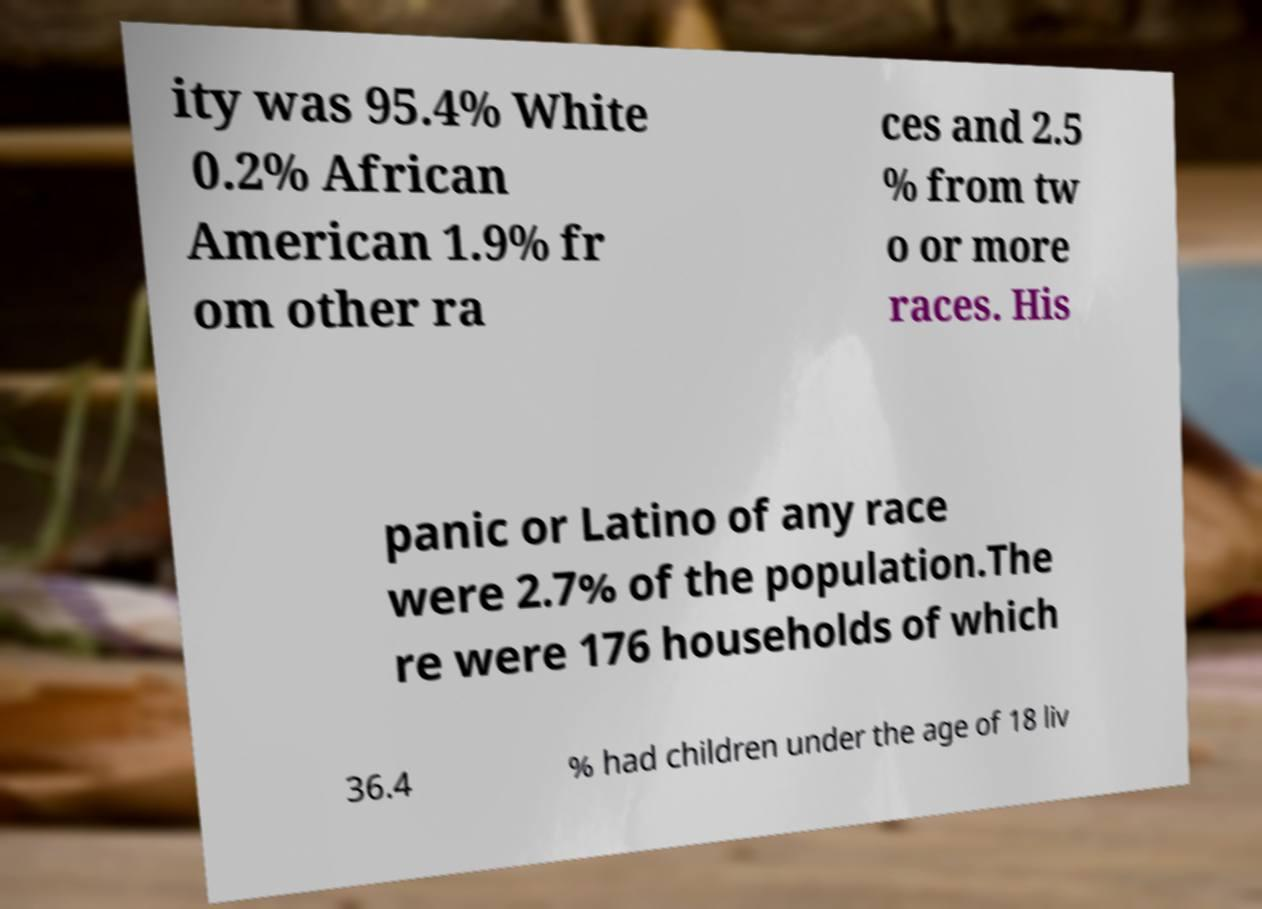What messages or text are displayed in this image? I need them in a readable, typed format. ity was 95.4% White 0.2% African American 1.9% fr om other ra ces and 2.5 % from tw o or more races. His panic or Latino of any race were 2.7% of the population.The re were 176 households of which 36.4 % had children under the age of 18 liv 